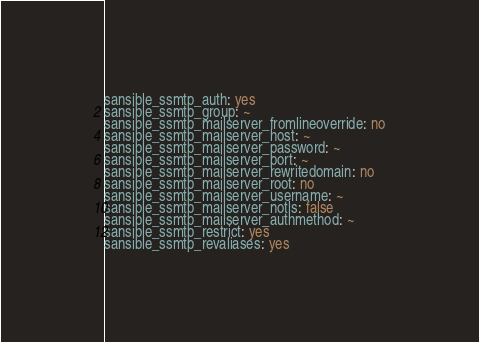<code> <loc_0><loc_0><loc_500><loc_500><_YAML_>
sansible_ssmtp_auth: yes
sansible_ssmtp_group: ~
sansible_ssmtp_mailserver_fromlineoverride: no
sansible_ssmtp_mailserver_host: ~
sansible_ssmtp_mailserver_password: ~
sansible_ssmtp_mailserver_port: ~
sansible_ssmtp_mailserver_rewritedomain: no
sansible_ssmtp_mailserver_root: no
sansible_ssmtp_mailserver_username: ~
sansible_ssmtp_mailserver_notls: false
sansible_ssmtp_mailserver_authmethod: ~
sansible_ssmtp_restrict: yes
sansible_ssmtp_revaliases: yes</code> 